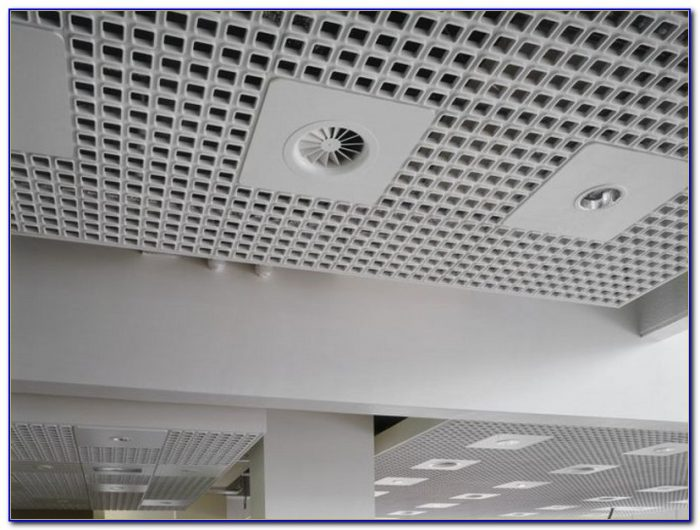Can you explain why the choice of material and color might be significant for the ceiling's functionality and design? The materials and colors chosen for the ceiling play a vital role in its performance and aesthetic appeal. The light gray color helps in scattering light uniformly, which is beneficial for creating a well-lit space without glare or sharp contrasts. This choice can enhance visual comfort and productivity. The material appears to be a lightweight, porous tile, which is effective for acoustic management by absorbing sound, thus improving auditory comfort. Moreover, the use of such materials can contribute to energy efficiency and ease of maintenance, aligning with contemporary design principles that favor functionality infused with style.  Are there any possible improvements or alternatives to the current ceiling design that could enhance its effectiveness or appearance? One potential improvement could involve integrating smart technology with the existing fixtures for enhanced control over the environment. For example, smart sensors could adjust lighting and air quality based on the number of occupants or time of day. Aesthetically, incorporating varied textures or patterns could break the monotony and imbue the space with more visual interest without compromising functionality. Additionally, exploring sustainable materials could also reflect environmental consciousness and potentially improve energy efficiency. 